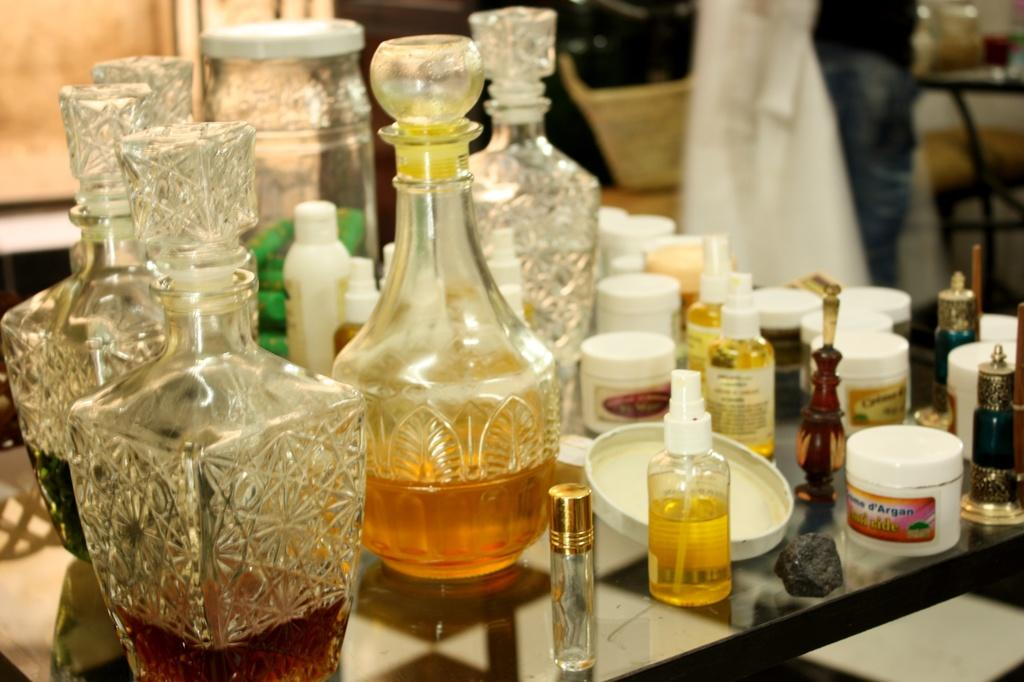<image>
Write a terse but informative summary of the picture. a small white box has an argan logo on it with glasses next to it 